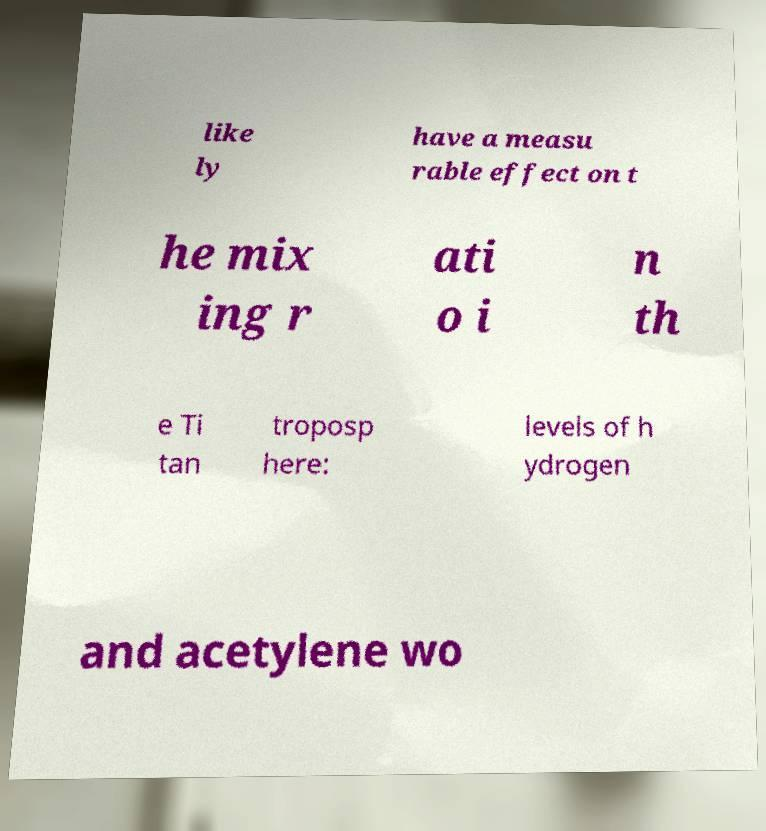Could you assist in decoding the text presented in this image and type it out clearly? like ly have a measu rable effect on t he mix ing r ati o i n th e Ti tan troposp here: levels of h ydrogen and acetylene wo 